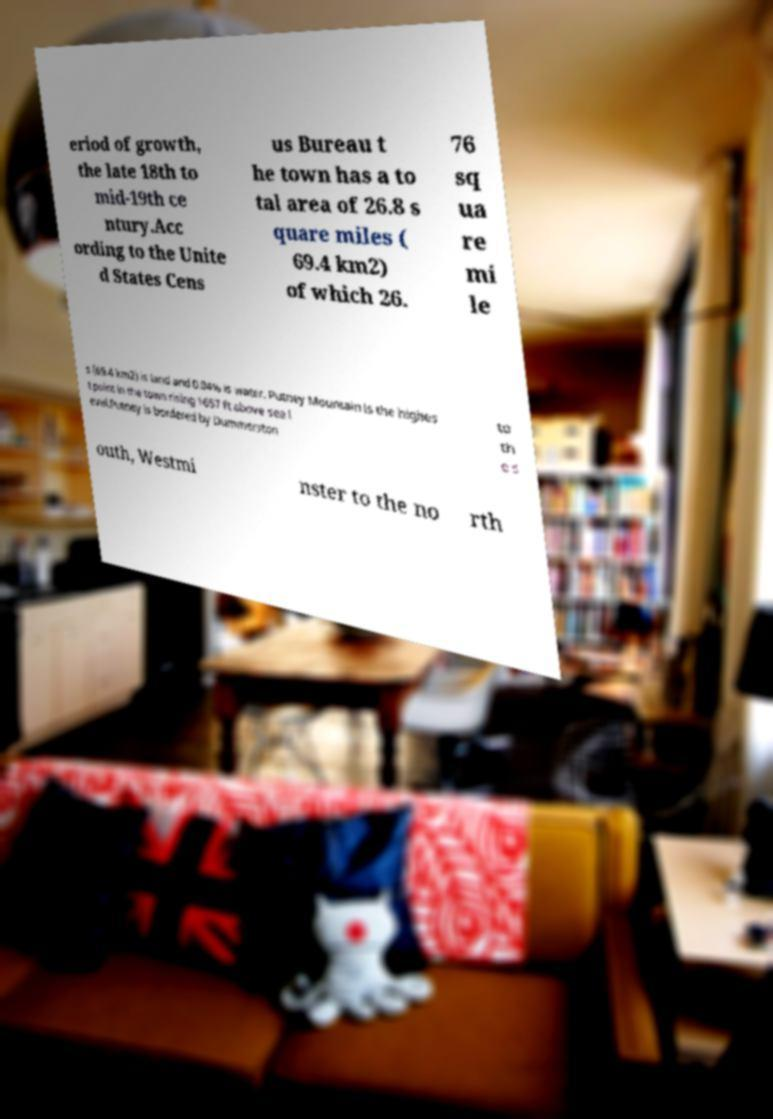For documentation purposes, I need the text within this image transcribed. Could you provide that? eriod of growth, the late 18th to mid-19th ce ntury.Acc ording to the Unite d States Cens us Bureau t he town has a to tal area of 26.8 s quare miles ( 69.4 km2) of which 26. 76 sq ua re mi le s (69.4 km2) is land and 0.04% is water. Putney Mountain is the highes t point in the town rising 1657 ft above sea l evel.Putney is bordered by Dummerston to th e s outh, Westmi nster to the no rth 